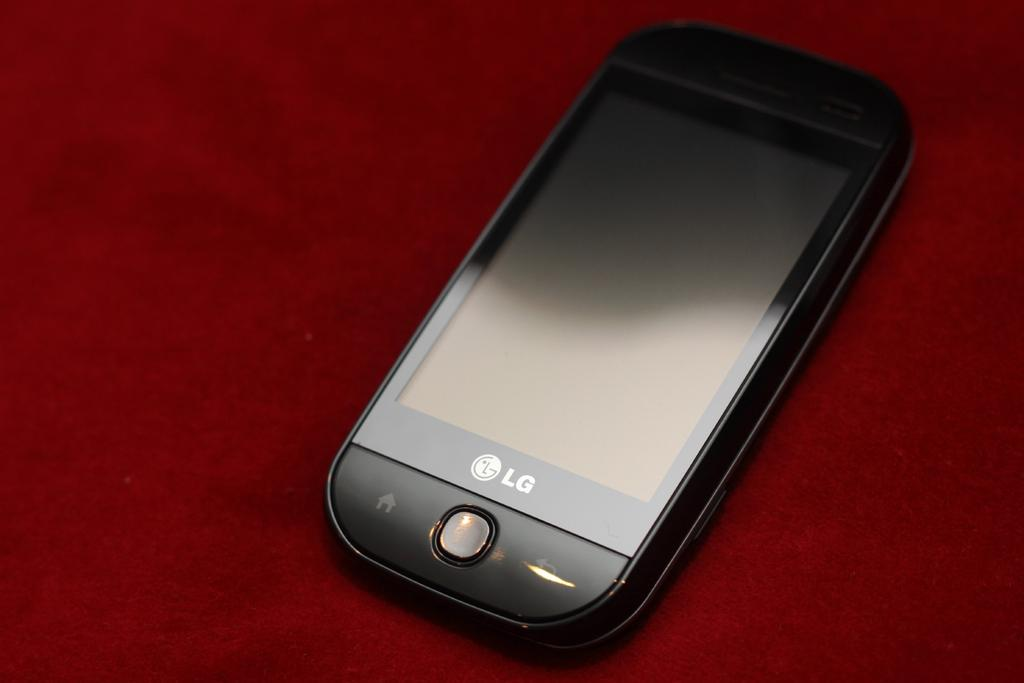<image>
Describe the image concisely. Black LG cellphone on top of a red surface. 